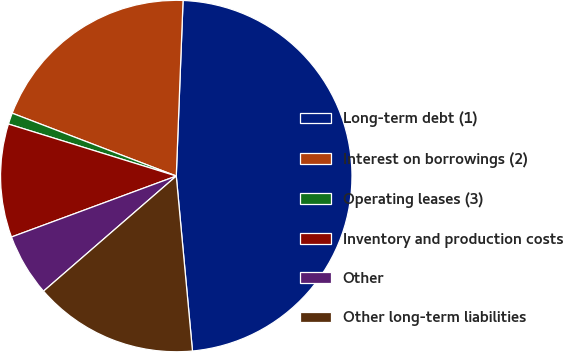Convert chart. <chart><loc_0><loc_0><loc_500><loc_500><pie_chart><fcel>Long-term debt (1)<fcel>Interest on borrowings (2)<fcel>Operating leases (3)<fcel>Inventory and production costs<fcel>Other<fcel>Other long-term liabilities<nl><fcel>47.91%<fcel>19.79%<fcel>1.04%<fcel>10.42%<fcel>5.73%<fcel>15.1%<nl></chart> 